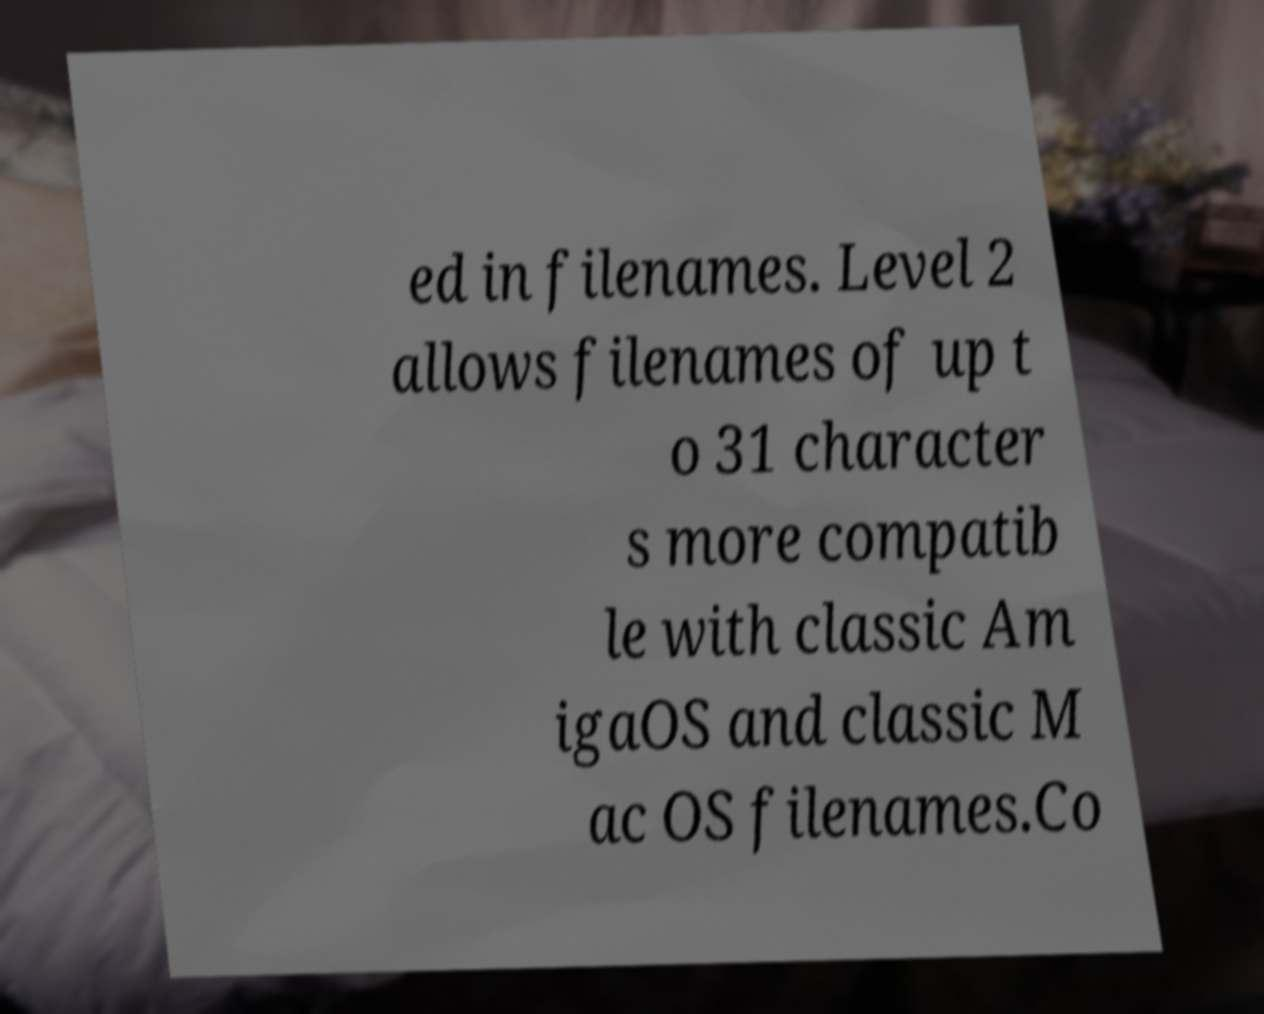Could you assist in decoding the text presented in this image and type it out clearly? ed in filenames. Level 2 allows filenames of up t o 31 character s more compatib le with classic Am igaOS and classic M ac OS filenames.Co 